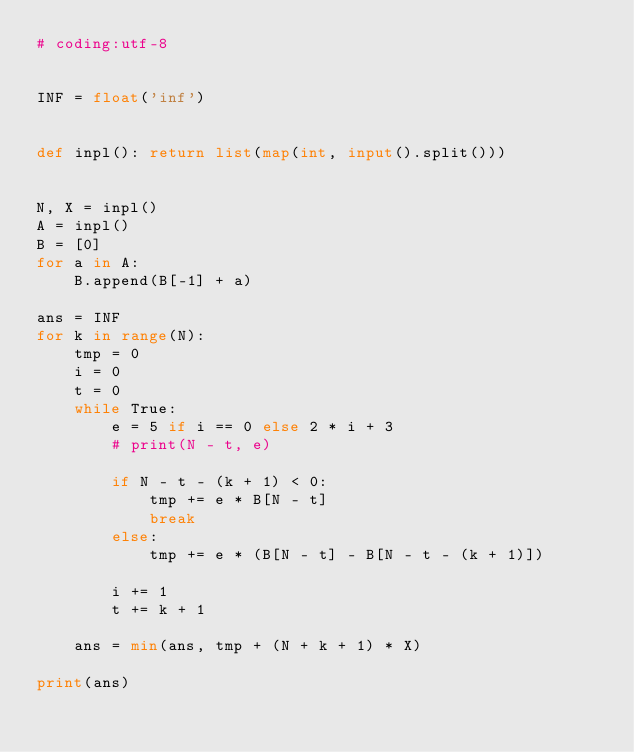<code> <loc_0><loc_0><loc_500><loc_500><_Python_># coding:utf-8


INF = float('inf')


def inpl(): return list(map(int, input().split()))


N, X = inpl()
A = inpl()
B = [0]
for a in A:
    B.append(B[-1] + a)

ans = INF
for k in range(N):
    tmp = 0
    i = 0
    t = 0
    while True:
        e = 5 if i == 0 else 2 * i + 3
        # print(N - t, e)

        if N - t - (k + 1) < 0:
            tmp += e * B[N - t]
            break
        else:
            tmp += e * (B[N - t] - B[N - t - (k + 1)])

        i += 1
        t += k + 1

    ans = min(ans, tmp + (N + k + 1) * X)

print(ans)</code> 